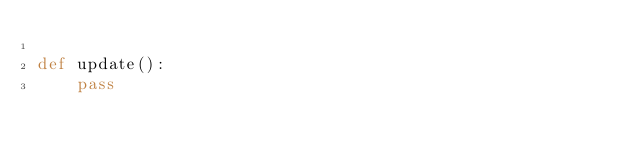Convert code to text. <code><loc_0><loc_0><loc_500><loc_500><_Python_>
def update():
    pass

</code> 